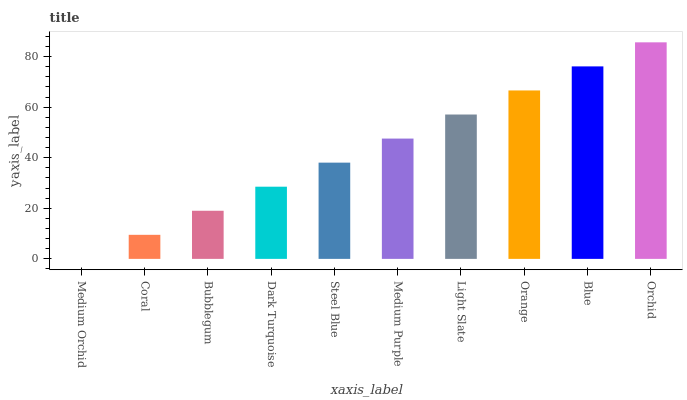Is Coral the minimum?
Answer yes or no. No. Is Coral the maximum?
Answer yes or no. No. Is Coral greater than Medium Orchid?
Answer yes or no. Yes. Is Medium Orchid less than Coral?
Answer yes or no. Yes. Is Medium Orchid greater than Coral?
Answer yes or no. No. Is Coral less than Medium Orchid?
Answer yes or no. No. Is Medium Purple the high median?
Answer yes or no. Yes. Is Steel Blue the low median?
Answer yes or no. Yes. Is Steel Blue the high median?
Answer yes or no. No. Is Bubblegum the low median?
Answer yes or no. No. 